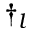Convert formula to latex. <formula><loc_0><loc_0><loc_500><loc_500>\dagger _ { l }</formula> 